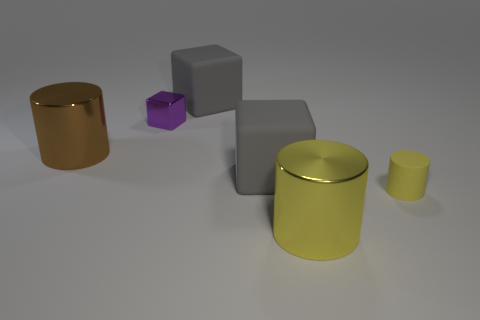Add 1 purple things. How many objects exist? 7 Subtract all big yellow metallic cylinders. How many cylinders are left? 2 Add 4 tiny yellow matte cylinders. How many tiny yellow matte cylinders exist? 5 Subtract all purple blocks. How many blocks are left? 2 Subtract 0 red spheres. How many objects are left? 6 Subtract 2 blocks. How many blocks are left? 1 Subtract all yellow cubes. Subtract all purple cylinders. How many cubes are left? 3 Subtract all cyan balls. How many yellow cylinders are left? 2 Subtract all gray cubes. Subtract all gray matte cubes. How many objects are left? 2 Add 1 big yellow objects. How many big yellow objects are left? 2 